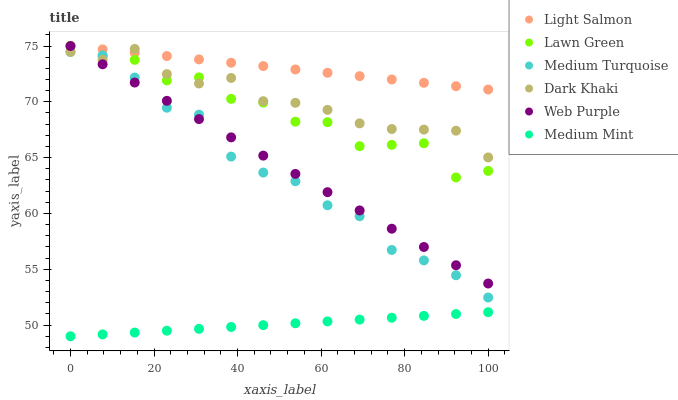Does Medium Mint have the minimum area under the curve?
Answer yes or no. Yes. Does Light Salmon have the maximum area under the curve?
Answer yes or no. Yes. Does Lawn Green have the minimum area under the curve?
Answer yes or no. No. Does Lawn Green have the maximum area under the curve?
Answer yes or no. No. Is Web Purple the smoothest?
Answer yes or no. Yes. Is Lawn Green the roughest?
Answer yes or no. Yes. Is Light Salmon the smoothest?
Answer yes or no. No. Is Light Salmon the roughest?
Answer yes or no. No. Does Medium Mint have the lowest value?
Answer yes or no. Yes. Does Lawn Green have the lowest value?
Answer yes or no. No. Does Web Purple have the highest value?
Answer yes or no. Yes. Does Dark Khaki have the highest value?
Answer yes or no. No. Is Medium Mint less than Medium Turquoise?
Answer yes or no. Yes. Is Dark Khaki greater than Medium Mint?
Answer yes or no. Yes. Does Medium Turquoise intersect Dark Khaki?
Answer yes or no. Yes. Is Medium Turquoise less than Dark Khaki?
Answer yes or no. No. Is Medium Turquoise greater than Dark Khaki?
Answer yes or no. No. Does Medium Mint intersect Medium Turquoise?
Answer yes or no. No. 